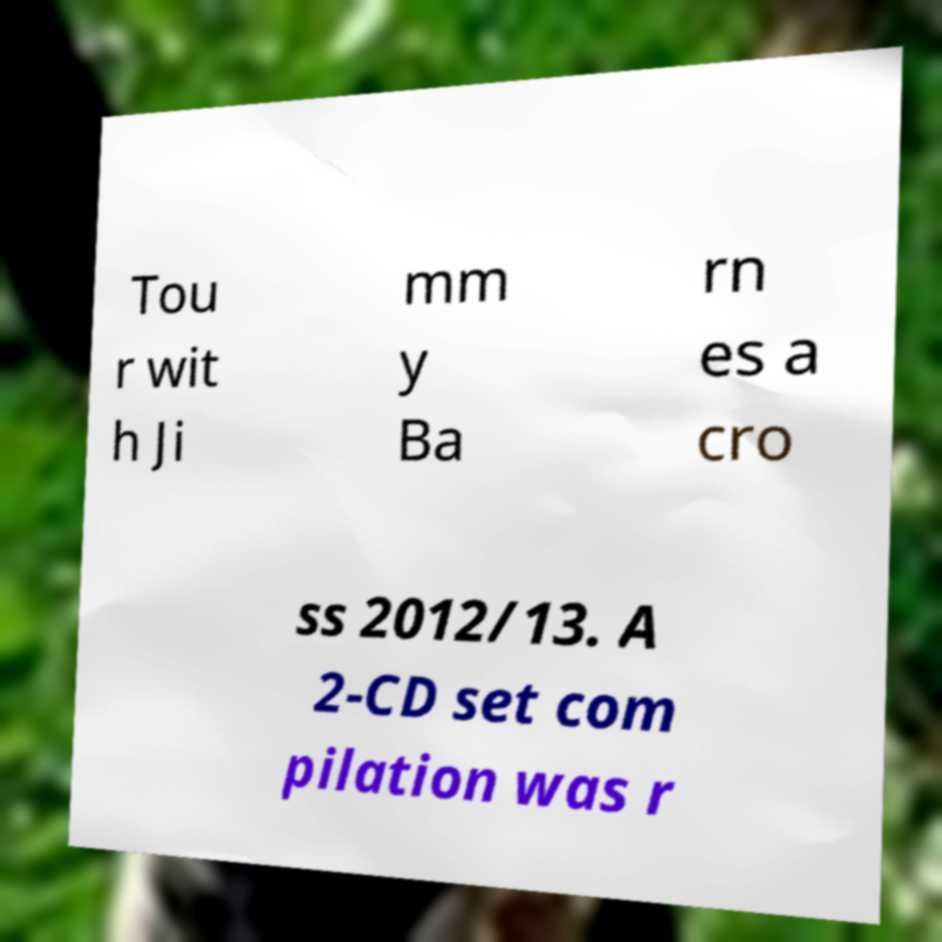Please identify and transcribe the text found in this image. Tou r wit h Ji mm y Ba rn es a cro ss 2012/13. A 2-CD set com pilation was r 